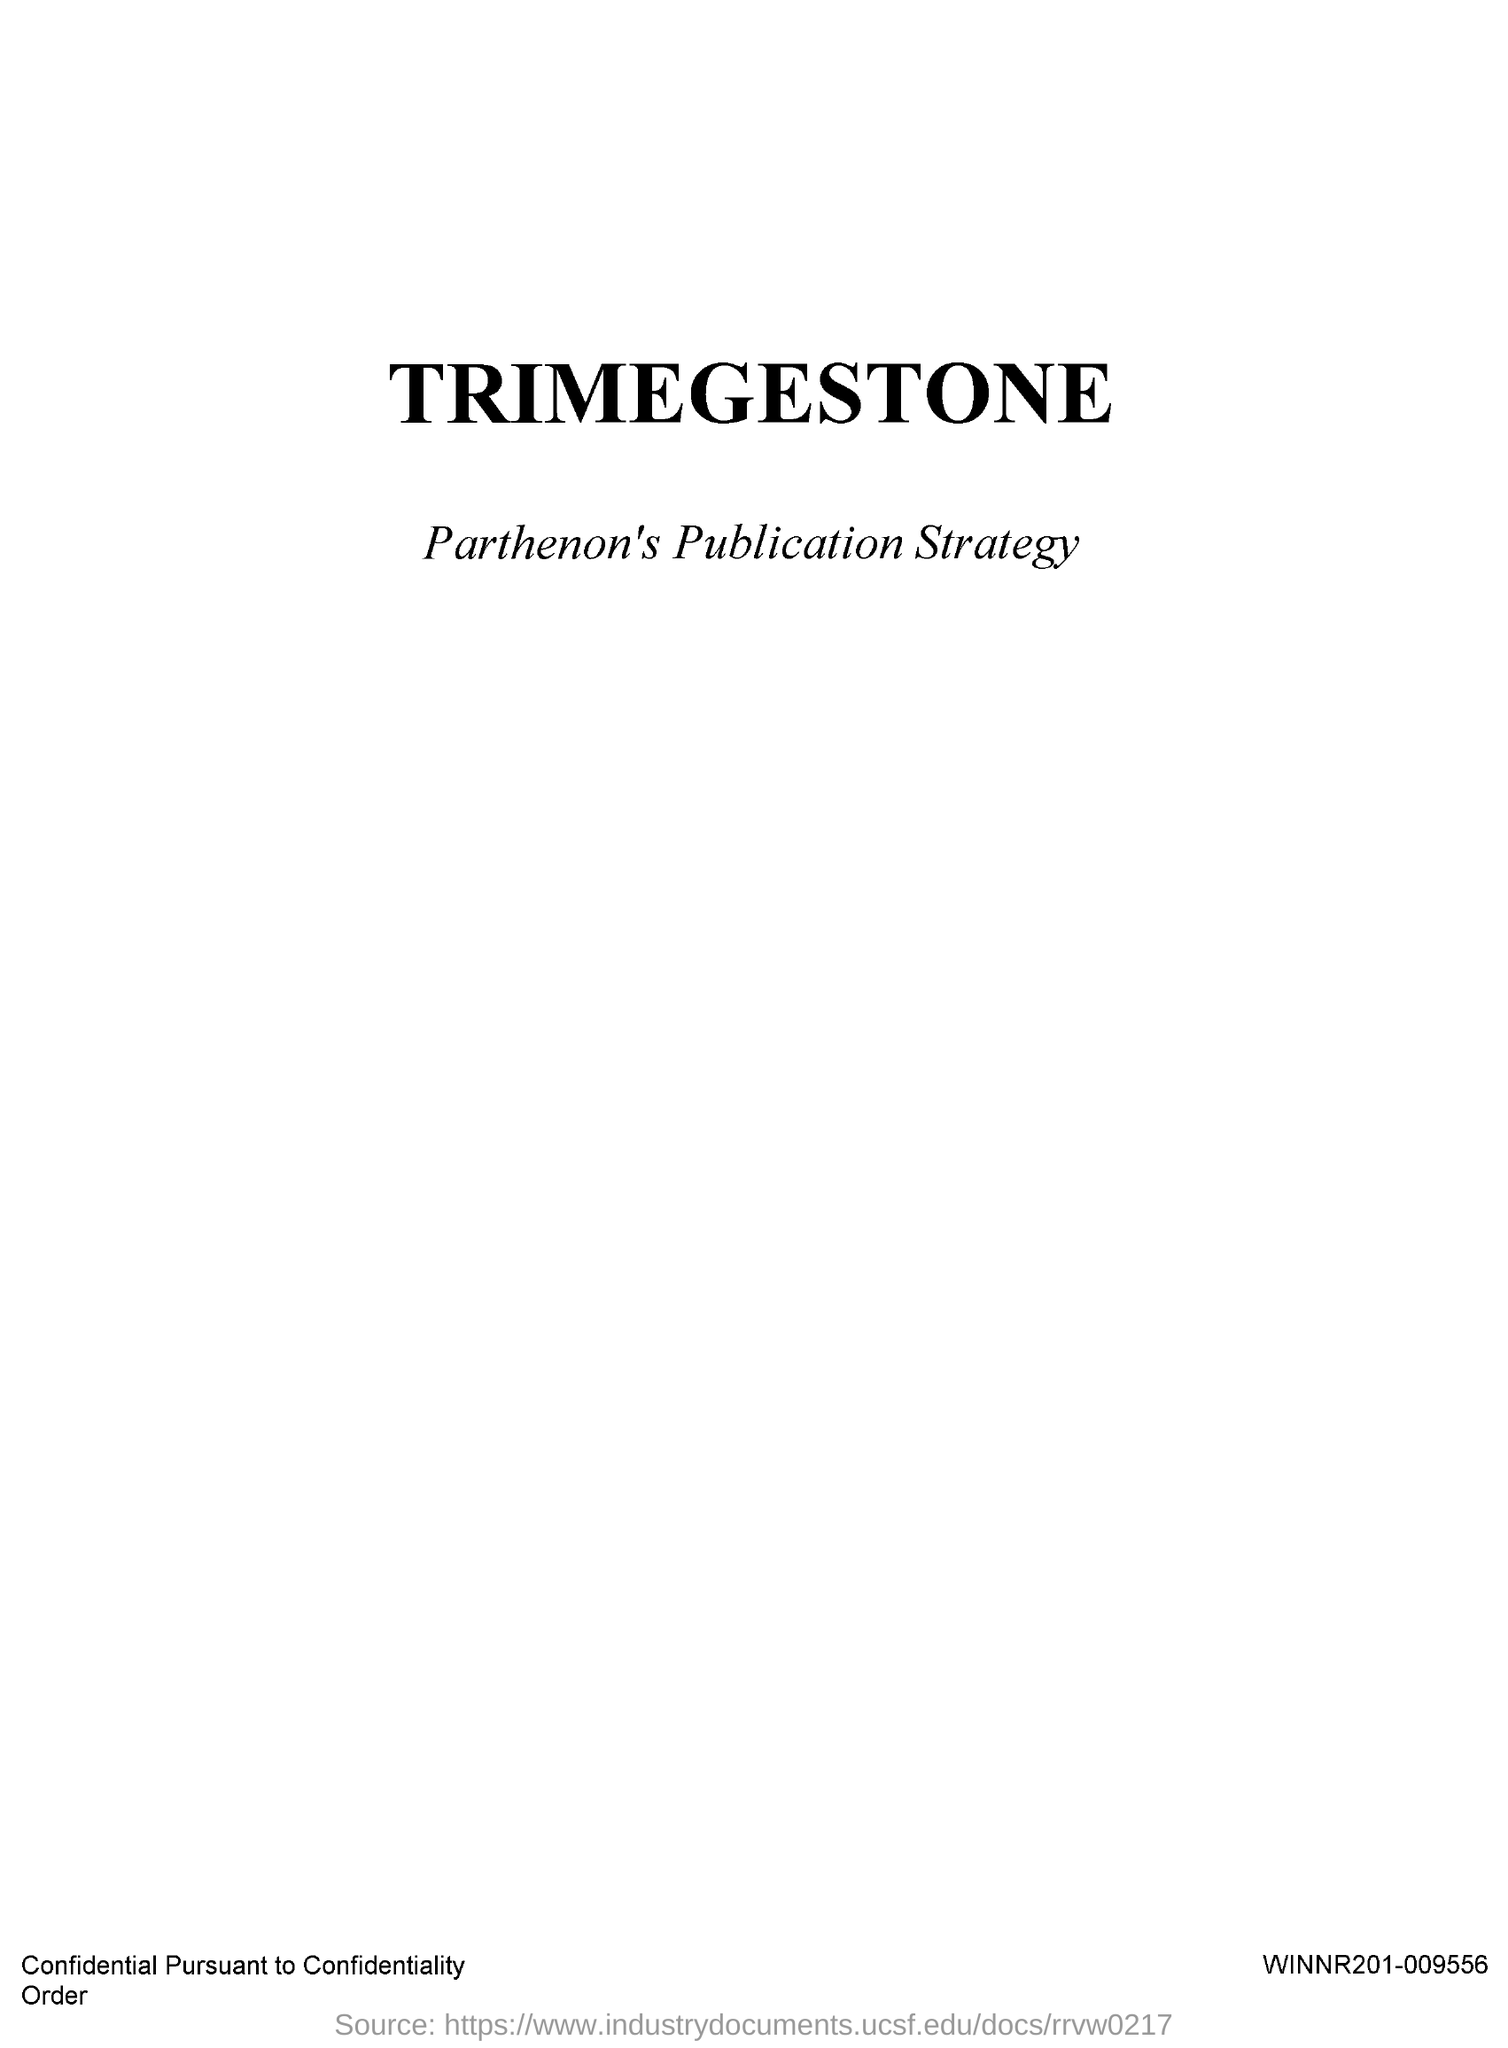Point out several critical features in this image. Trimegestone is the drug that is being referred to. 